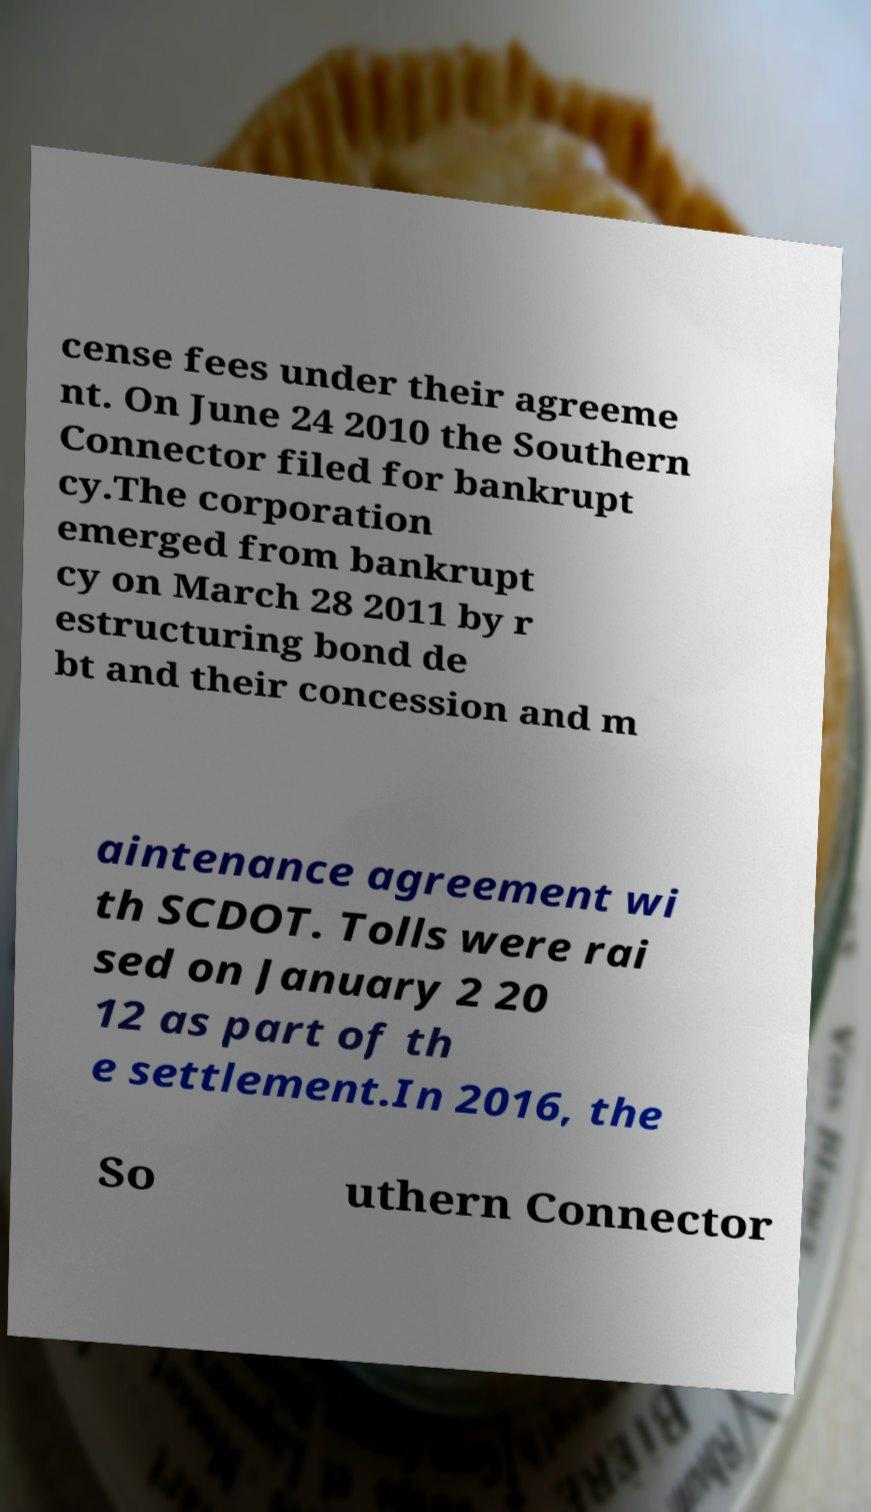Can you accurately transcribe the text from the provided image for me? cense fees under their agreeme nt. On June 24 2010 the Southern Connector filed for bankrupt cy.The corporation emerged from bankrupt cy on March 28 2011 by r estructuring bond de bt and their concession and m aintenance agreement wi th SCDOT. Tolls were rai sed on January 2 20 12 as part of th e settlement.In 2016, the So uthern Connector 